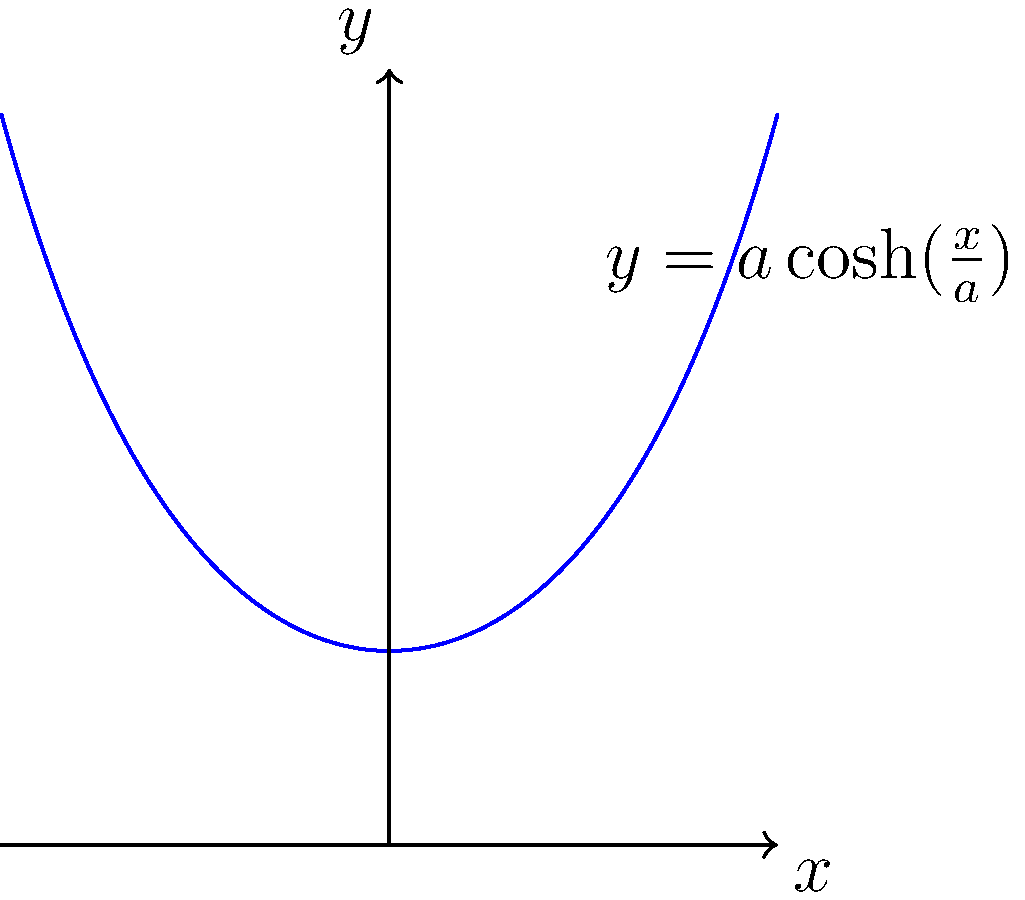Consider a catenary curve described by the equation $y = a \cosh(\frac{x}{a})$, where $a$ is a constant. In the context of bridge design, how does changing the value of $a$ affect the shape of the arch, and what implications does this have for the distribution of forces in the structure? To understand the effect of changing $a$ in the catenary equation $y = a \cosh(\frac{x}{a})$, let's analyze it step-by-step:

1) The catenary curve is the ideal shape for an arch that supports only its own weight. In bridge design, it's often used as a starting point for arch shapes.

2) The parameter $a$ in the equation is called the scale factor. It determines both the vertical scaling and the rate of change of the curve.

3) Mathematical analysis:
   - When $a$ increases:
     a) The curve becomes flatter and wider.
     b) The minimum point (vertex) of the curve rises.
   - When $a$ decreases:
     a) The curve becomes steeper and narrower.
     b) The minimum point of the curve lowers.

4) In terms of differential geometry:
   - The curvature of the catenary at any point is given by $\kappa = \frac{1}{a} \sech^2(\frac{x}{a})$.
   - As $a$ increases, the curvature decreases for all $x$, resulting in a flatter curve.

5) Implications for bridge design:
   - A larger $a$ results in a flatter arch, which:
     a) Distributes the load over a wider area.
     b) Reduces the vertical forces but increases horizontal thrust at the supports.
   - A smaller $a$ results in a steeper arch, which:
     a) Concentrates the load over a smaller area.
     b) Increases the vertical forces but reduces horizontal thrust at the supports.

6) The optimal value of $a$ depends on various factors including the span of the bridge, the expected loads, and the strength of the supporting structures.

7) In practice, pure catenary shapes are rarely used. Engineers often modify the catenary curve to account for non-uniform load distributions and other practical considerations.
Answer: Increasing $a$ flattens the arch, widening load distribution and increasing horizontal thrust. Decreasing $a$ steepens the arch, concentrating load and increasing vertical forces. 